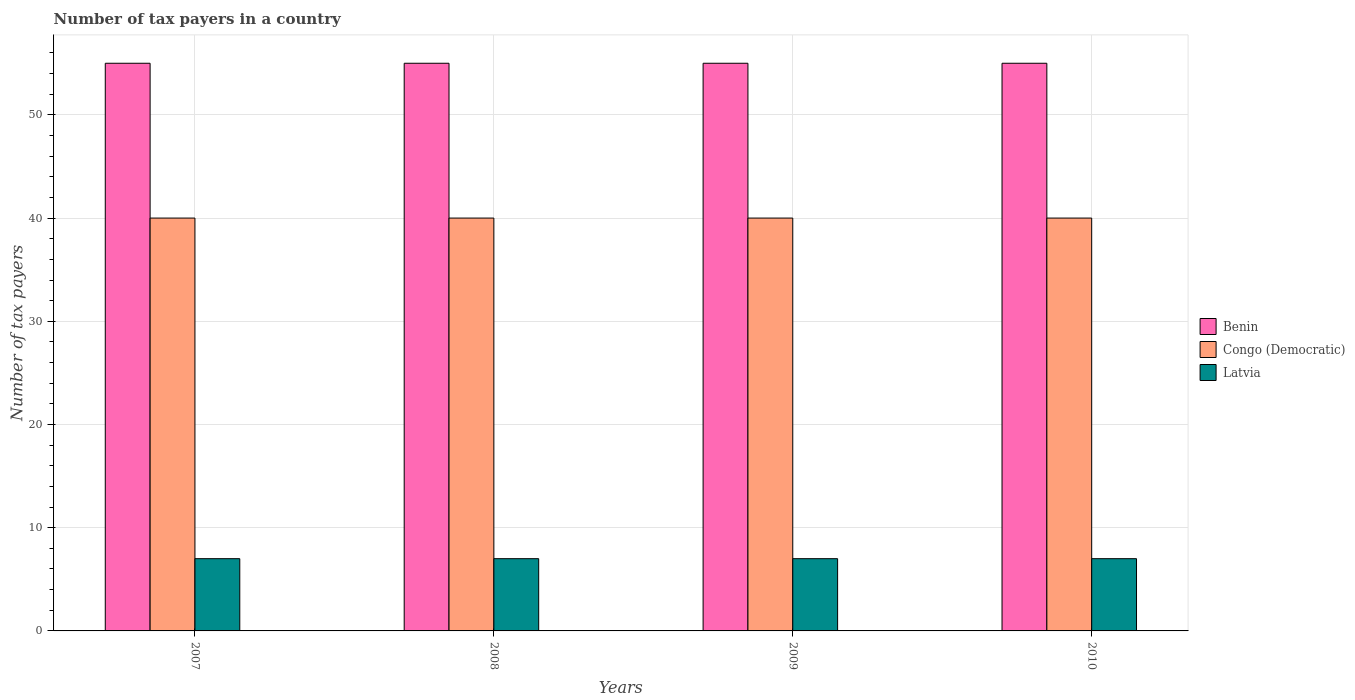How many groups of bars are there?
Ensure brevity in your answer.  4. How many bars are there on the 2nd tick from the left?
Your answer should be very brief. 3. What is the label of the 4th group of bars from the left?
Make the answer very short. 2010. In how many cases, is the number of bars for a given year not equal to the number of legend labels?
Offer a very short reply. 0. What is the number of tax payers in in Benin in 2008?
Offer a very short reply. 55. Across all years, what is the maximum number of tax payers in in Congo (Democratic)?
Your answer should be very brief. 40. Across all years, what is the minimum number of tax payers in in Latvia?
Keep it short and to the point. 7. In which year was the number of tax payers in in Latvia maximum?
Your response must be concise. 2007. What is the total number of tax payers in in Latvia in the graph?
Ensure brevity in your answer.  28. What is the difference between the number of tax payers in in Benin in 2008 and that in 2010?
Your response must be concise. 0. What is the difference between the number of tax payers in in Latvia in 2008 and the number of tax payers in in Congo (Democratic) in 2010?
Keep it short and to the point. -33. What is the average number of tax payers in in Benin per year?
Offer a very short reply. 55. In the year 2007, what is the difference between the number of tax payers in in Congo (Democratic) and number of tax payers in in Benin?
Provide a short and direct response. -15. What is the ratio of the number of tax payers in in Latvia in 2009 to that in 2010?
Make the answer very short. 1. What is the difference between the highest and the lowest number of tax payers in in Benin?
Give a very brief answer. 0. What does the 3rd bar from the left in 2010 represents?
Keep it short and to the point. Latvia. What does the 2nd bar from the right in 2008 represents?
Your answer should be very brief. Congo (Democratic). Is it the case that in every year, the sum of the number of tax payers in in Latvia and number of tax payers in in Benin is greater than the number of tax payers in in Congo (Democratic)?
Give a very brief answer. Yes. How many bars are there?
Your response must be concise. 12. Does the graph contain any zero values?
Keep it short and to the point. No. Where does the legend appear in the graph?
Provide a short and direct response. Center right. How many legend labels are there?
Offer a very short reply. 3. How are the legend labels stacked?
Provide a short and direct response. Vertical. What is the title of the graph?
Your answer should be very brief. Number of tax payers in a country. Does "Sierra Leone" appear as one of the legend labels in the graph?
Your answer should be compact. No. What is the label or title of the Y-axis?
Provide a short and direct response. Number of tax payers. What is the Number of tax payers in Benin in 2007?
Your answer should be very brief. 55. What is the Number of tax payers of Congo (Democratic) in 2007?
Make the answer very short. 40. What is the Number of tax payers in Benin in 2008?
Provide a short and direct response. 55. What is the Number of tax payers in Latvia in 2008?
Your answer should be compact. 7. What is the Number of tax payers of Benin in 2009?
Ensure brevity in your answer.  55. Across all years, what is the maximum Number of tax payers in Latvia?
Offer a very short reply. 7. Across all years, what is the minimum Number of tax payers of Benin?
Provide a short and direct response. 55. Across all years, what is the minimum Number of tax payers of Latvia?
Ensure brevity in your answer.  7. What is the total Number of tax payers of Benin in the graph?
Your response must be concise. 220. What is the total Number of tax payers of Congo (Democratic) in the graph?
Offer a very short reply. 160. What is the total Number of tax payers in Latvia in the graph?
Your answer should be compact. 28. What is the difference between the Number of tax payers in Benin in 2007 and that in 2008?
Make the answer very short. 0. What is the difference between the Number of tax payers of Congo (Democratic) in 2007 and that in 2008?
Offer a very short reply. 0. What is the difference between the Number of tax payers of Congo (Democratic) in 2007 and that in 2009?
Give a very brief answer. 0. What is the difference between the Number of tax payers in Latvia in 2007 and that in 2009?
Your response must be concise. 0. What is the difference between the Number of tax payers of Latvia in 2007 and that in 2010?
Provide a succinct answer. 0. What is the difference between the Number of tax payers of Benin in 2008 and that in 2009?
Ensure brevity in your answer.  0. What is the difference between the Number of tax payers of Congo (Democratic) in 2008 and that in 2009?
Ensure brevity in your answer.  0. What is the difference between the Number of tax payers of Latvia in 2008 and that in 2009?
Offer a terse response. 0. What is the difference between the Number of tax payers in Congo (Democratic) in 2008 and that in 2010?
Keep it short and to the point. 0. What is the difference between the Number of tax payers in Latvia in 2008 and that in 2010?
Ensure brevity in your answer.  0. What is the difference between the Number of tax payers of Benin in 2007 and the Number of tax payers of Congo (Democratic) in 2009?
Offer a very short reply. 15. What is the difference between the Number of tax payers in Congo (Democratic) in 2007 and the Number of tax payers in Latvia in 2009?
Your answer should be compact. 33. What is the difference between the Number of tax payers in Benin in 2007 and the Number of tax payers in Congo (Democratic) in 2010?
Ensure brevity in your answer.  15. What is the difference between the Number of tax payers in Benin in 2007 and the Number of tax payers in Latvia in 2010?
Provide a succinct answer. 48. What is the difference between the Number of tax payers of Congo (Democratic) in 2007 and the Number of tax payers of Latvia in 2010?
Offer a terse response. 33. What is the difference between the Number of tax payers of Congo (Democratic) in 2008 and the Number of tax payers of Latvia in 2009?
Give a very brief answer. 33. What is the difference between the Number of tax payers in Benin in 2008 and the Number of tax payers in Congo (Democratic) in 2010?
Offer a terse response. 15. What is the difference between the Number of tax payers of Congo (Democratic) in 2009 and the Number of tax payers of Latvia in 2010?
Give a very brief answer. 33. What is the average Number of tax payers in Benin per year?
Your answer should be compact. 55. What is the average Number of tax payers in Congo (Democratic) per year?
Provide a succinct answer. 40. What is the average Number of tax payers of Latvia per year?
Make the answer very short. 7. In the year 2007, what is the difference between the Number of tax payers of Benin and Number of tax payers of Latvia?
Make the answer very short. 48. In the year 2008, what is the difference between the Number of tax payers in Benin and Number of tax payers in Congo (Democratic)?
Your answer should be very brief. 15. In the year 2008, what is the difference between the Number of tax payers in Benin and Number of tax payers in Latvia?
Provide a succinct answer. 48. In the year 2010, what is the difference between the Number of tax payers in Benin and Number of tax payers in Congo (Democratic)?
Keep it short and to the point. 15. In the year 2010, what is the difference between the Number of tax payers in Congo (Democratic) and Number of tax payers in Latvia?
Make the answer very short. 33. What is the ratio of the Number of tax payers in Benin in 2007 to that in 2009?
Give a very brief answer. 1. What is the ratio of the Number of tax payers in Congo (Democratic) in 2007 to that in 2009?
Your response must be concise. 1. What is the ratio of the Number of tax payers in Benin in 2007 to that in 2010?
Ensure brevity in your answer.  1. What is the ratio of the Number of tax payers of Latvia in 2008 to that in 2010?
Offer a very short reply. 1. What is the ratio of the Number of tax payers in Latvia in 2009 to that in 2010?
Offer a very short reply. 1. What is the difference between the highest and the second highest Number of tax payers of Benin?
Your answer should be very brief. 0. What is the difference between the highest and the second highest Number of tax payers in Latvia?
Provide a succinct answer. 0. What is the difference between the highest and the lowest Number of tax payers in Benin?
Provide a succinct answer. 0. What is the difference between the highest and the lowest Number of tax payers in Congo (Democratic)?
Make the answer very short. 0. 